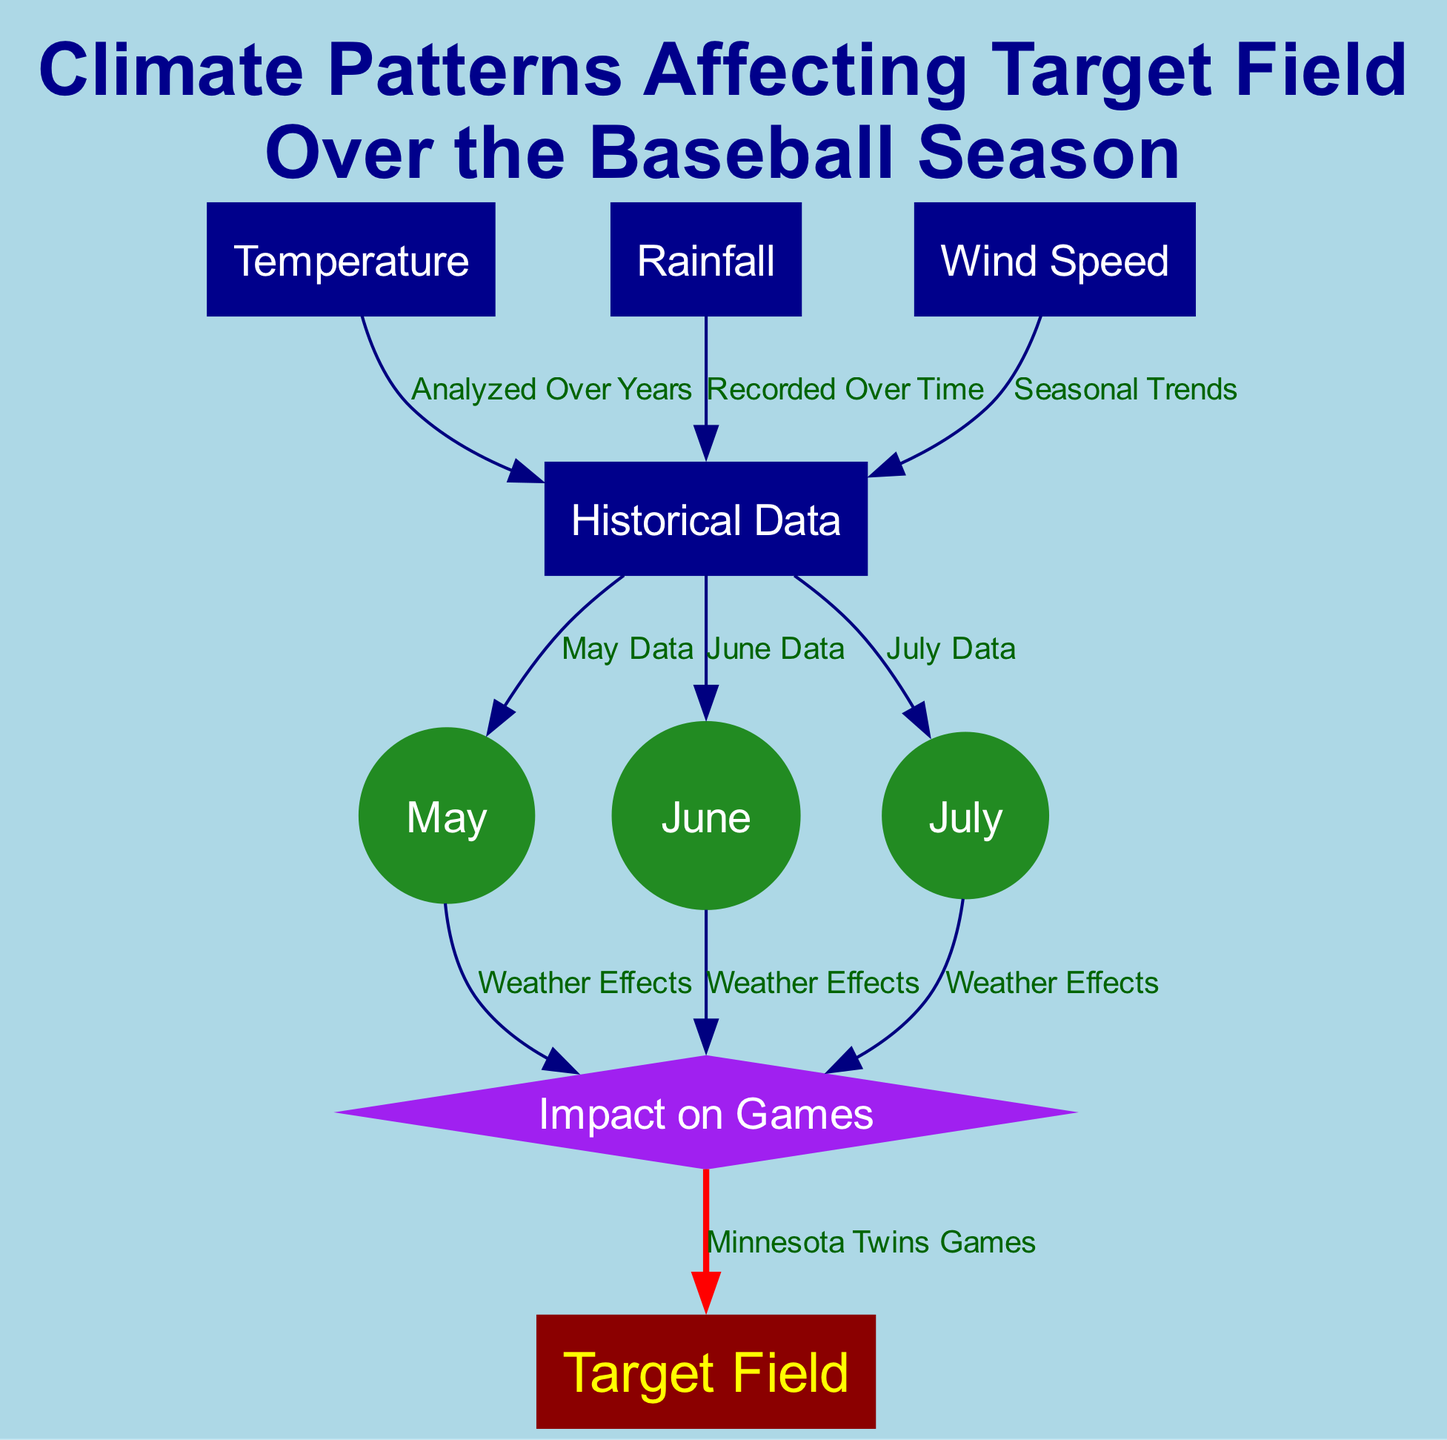What are the three climate factors analyzed in the diagram? The diagram identifies three climate factors: Temperature, Rainfall, and Wind Speed as nodes that influence Target Field. Each of these has a distinct node in the diagram.
Answer: Temperature, Rainfall, Wind Speed How many months of data are included in the historical analysis? The historical data node connects to three separate month nodes: May, June, and July. Each month represents a segment of the baseball season that has been analyzed in the context of historical weather data.
Answer: Three Which month directly impacts the games at Target Field? The impact node connects directly to the month nodes (May, June, July), indicating that all three months influence the games at Target Field. The diagram shows these relationships distinctly.
Answer: All three months What is the relationship between rainfall and historical data? The edge labeled "Recorded Over Time" illustrates that rainfall is analyzed in the context of historical data. This means that data about rainfall is compiled over previous seasons to understand its effects on baseball games.
Answer: Recorded Over Time How does wind speed relate to the historical data? The edge labeled "Seasonal Trends" illustrates that wind speed is analyzed as part of the historical data collected over the years. This implies that fluctuations in wind speed throughout the seasons have been documented and considered for their impact on games.
Answer: Seasonal Trends Which factor has a direct line to "Minnesota Twins Games"? The impact node, which is affected by the month nodes (May, June, July), connects to the "Minnesota Twins Games." This indicates that the weather conditions during these months directly influence the games played at Target Field.
Answer: Impact What shape categorizes the target field node in the diagram? The target field node is represented with a unique shape that stands out from others in the diagram. It is designated as a stadium shape, which signifies its importance as the location of the Minnesota Twins games.
Answer: Stadium What color represents the rainfall node? The diagram assigns a specific color to the rainfall node, distinguishing it visually from other nodes. This color coding serves to enhance clarity and categorization of the different climate factors represented.
Answer: Dark blue 